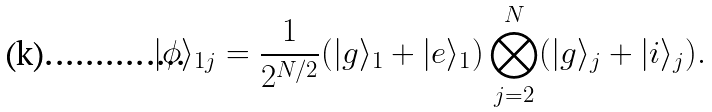<formula> <loc_0><loc_0><loc_500><loc_500>| \phi \rangle _ { 1 j } = \frac { 1 } { 2 ^ { N / 2 } } ( | g \rangle _ { 1 } + | e \rangle _ { 1 } ) \bigotimes _ { j = 2 } ^ { N } ( | g \rangle _ { j } + | i \rangle _ { j } ) .</formula> 